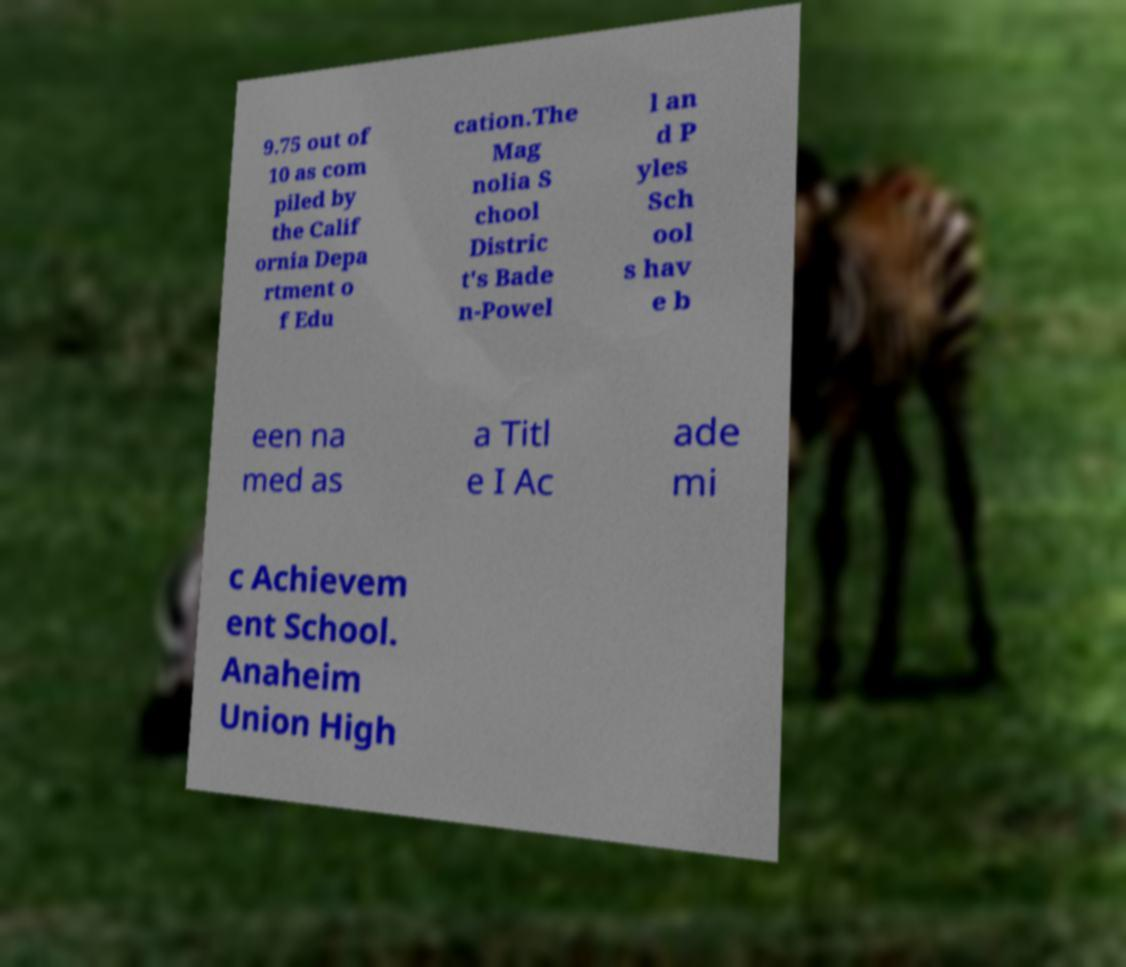I need the written content from this picture converted into text. Can you do that? 9.75 out of 10 as com piled by the Calif ornia Depa rtment o f Edu cation.The Mag nolia S chool Distric t's Bade n-Powel l an d P yles Sch ool s hav e b een na med as a Titl e I Ac ade mi c Achievem ent School. Anaheim Union High 